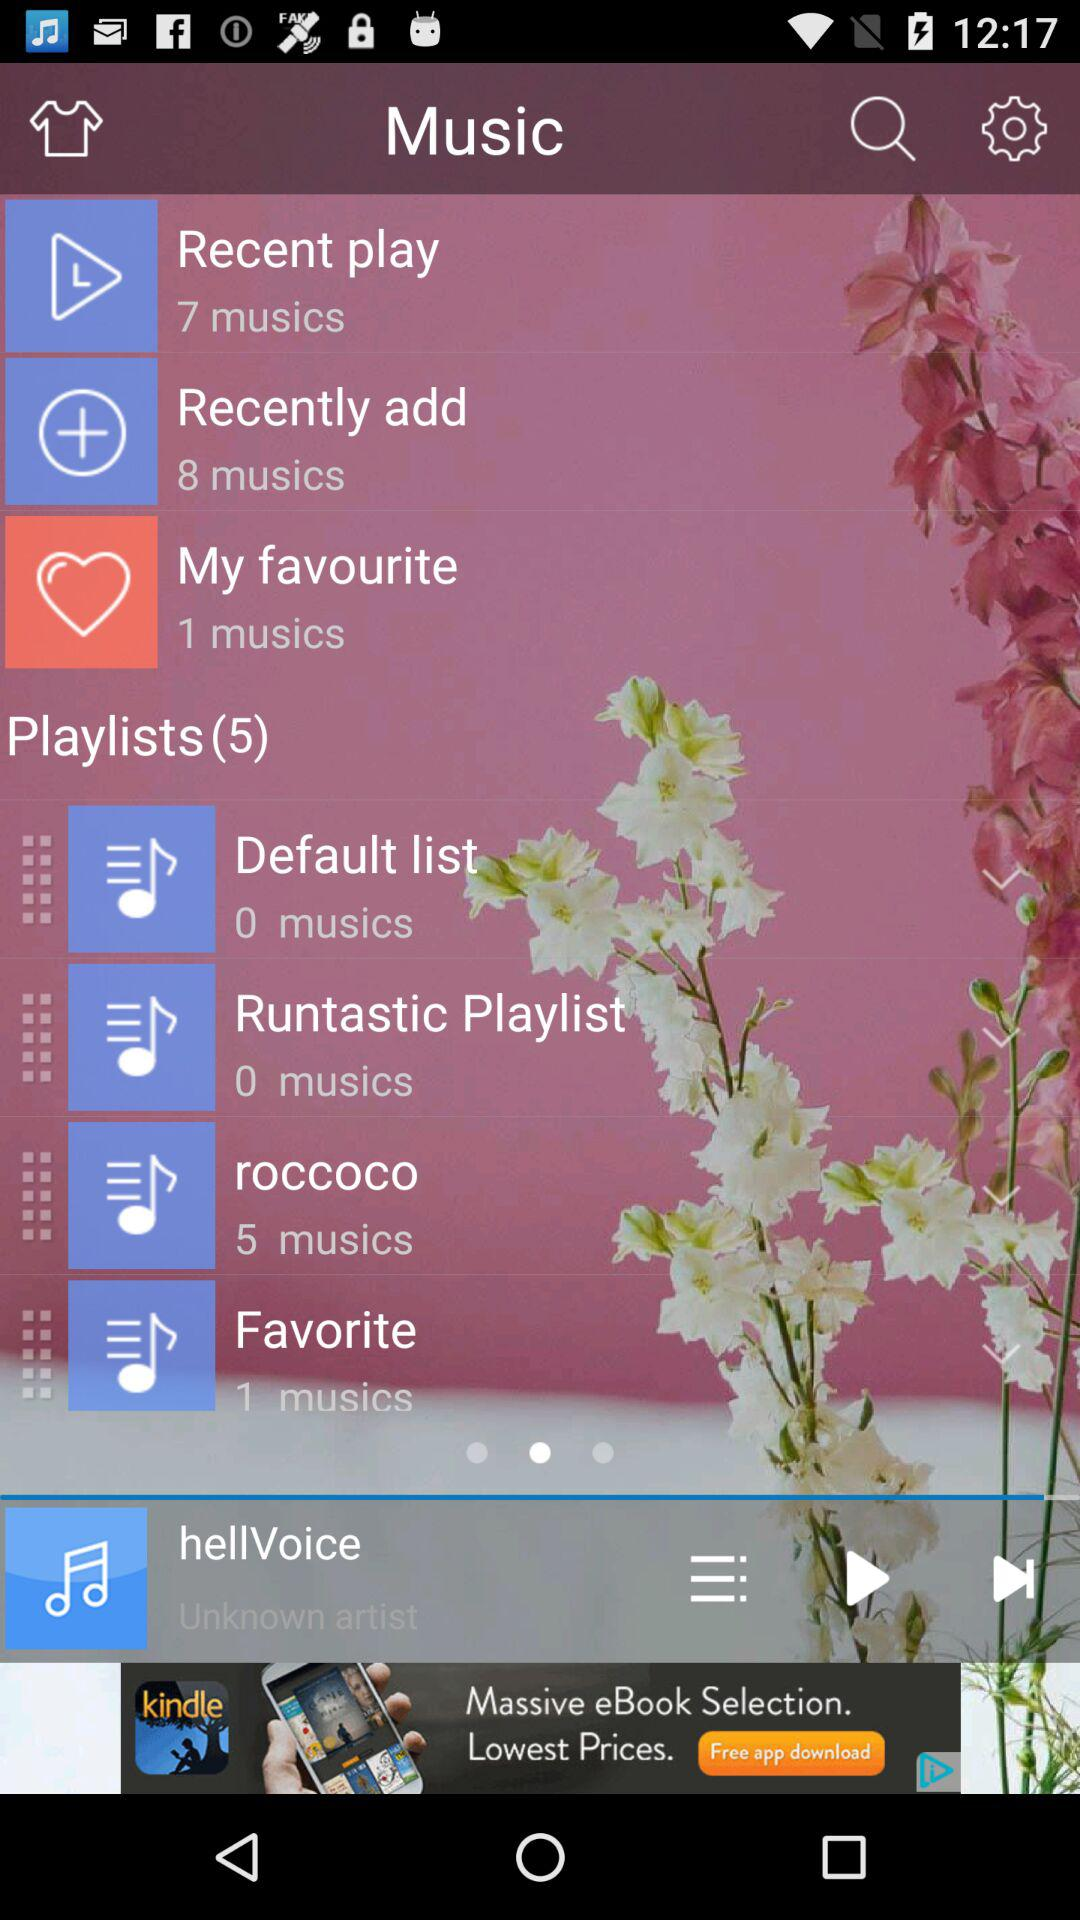What is the number of music in "Recent play"? The number of music is 7. 